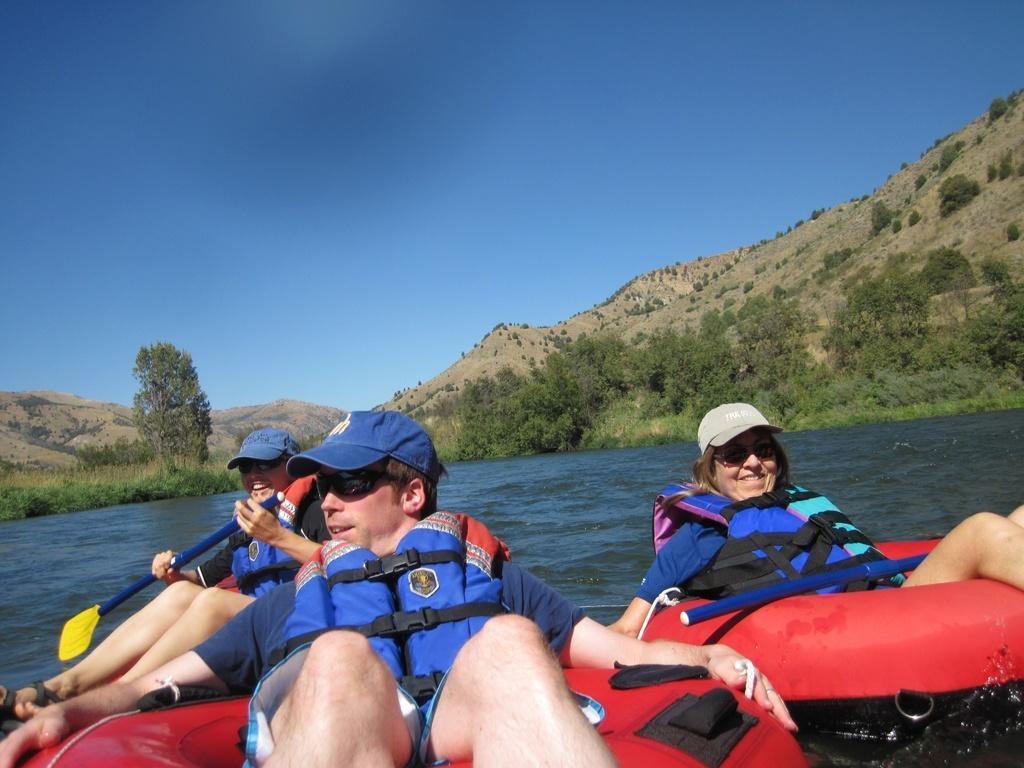Can you describe this image briefly? In this picture I can see the people rafting. I can see water. I can see trees. I can see the hill. I can see clouds in the sky. 